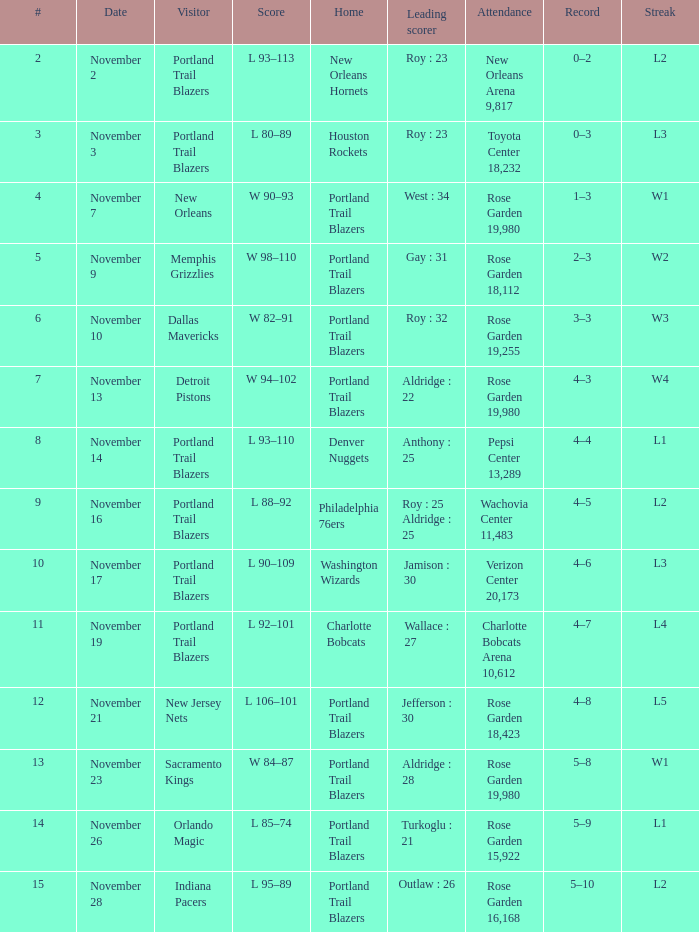Can you give me this table as a dict? {'header': ['#', 'Date', 'Visitor', 'Score', 'Home', 'Leading scorer', 'Attendance', 'Record', 'Streak'], 'rows': [['2', 'November 2', 'Portland Trail Blazers', 'L 93–113', 'New Orleans Hornets', 'Roy : 23', 'New Orleans Arena 9,817', '0–2', 'L2'], ['3', 'November 3', 'Portland Trail Blazers', 'L 80–89', 'Houston Rockets', 'Roy : 23', 'Toyota Center 18,232', '0–3', 'L3'], ['4', 'November 7', 'New Orleans', 'W 90–93', 'Portland Trail Blazers', 'West : 34', 'Rose Garden 19,980', '1–3', 'W1'], ['5', 'November 9', 'Memphis Grizzlies', 'W 98–110', 'Portland Trail Blazers', 'Gay : 31', 'Rose Garden 18,112', '2–3', 'W2'], ['6', 'November 10', 'Dallas Mavericks', 'W 82–91', 'Portland Trail Blazers', 'Roy : 32', 'Rose Garden 19,255', '3–3', 'W3'], ['7', 'November 13', 'Detroit Pistons', 'W 94–102', 'Portland Trail Blazers', 'Aldridge : 22', 'Rose Garden 19,980', '4–3', 'W4'], ['8', 'November 14', 'Portland Trail Blazers', 'L 93–110', 'Denver Nuggets', 'Anthony : 25', 'Pepsi Center 13,289', '4–4', 'L1'], ['9', 'November 16', 'Portland Trail Blazers', 'L 88–92', 'Philadelphia 76ers', 'Roy : 25 Aldridge : 25', 'Wachovia Center 11,483', '4–5', 'L2'], ['10', 'November 17', 'Portland Trail Blazers', 'L 90–109', 'Washington Wizards', 'Jamison : 30', 'Verizon Center 20,173', '4–6', 'L3'], ['11', 'November 19', 'Portland Trail Blazers', 'L 92–101', 'Charlotte Bobcats', 'Wallace : 27', 'Charlotte Bobcats Arena 10,612', '4–7', 'L4'], ['12', 'November 21', 'New Jersey Nets', 'L 106–101', 'Portland Trail Blazers', 'Jefferson : 30', 'Rose Garden 18,423', '4–8', 'L5'], ['13', 'November 23', 'Sacramento Kings', 'W 84–87', 'Portland Trail Blazers', 'Aldridge : 28', 'Rose Garden 19,980', '5–8', 'W1'], ['14', 'November 26', 'Orlando Magic', 'L 85–74', 'Portland Trail Blazers', 'Turkoglu : 21', 'Rose Garden 15,922', '5–9', 'L1'], ['15', 'November 28', 'Indiana Pacers', 'L 95–89', 'Portland Trail Blazers', 'Outlaw : 26', 'Rose Garden 16,168', '5–10', 'L2']]}  what's the attendance where score is l 92–101 Charlotte Bobcats Arena 10,612. 